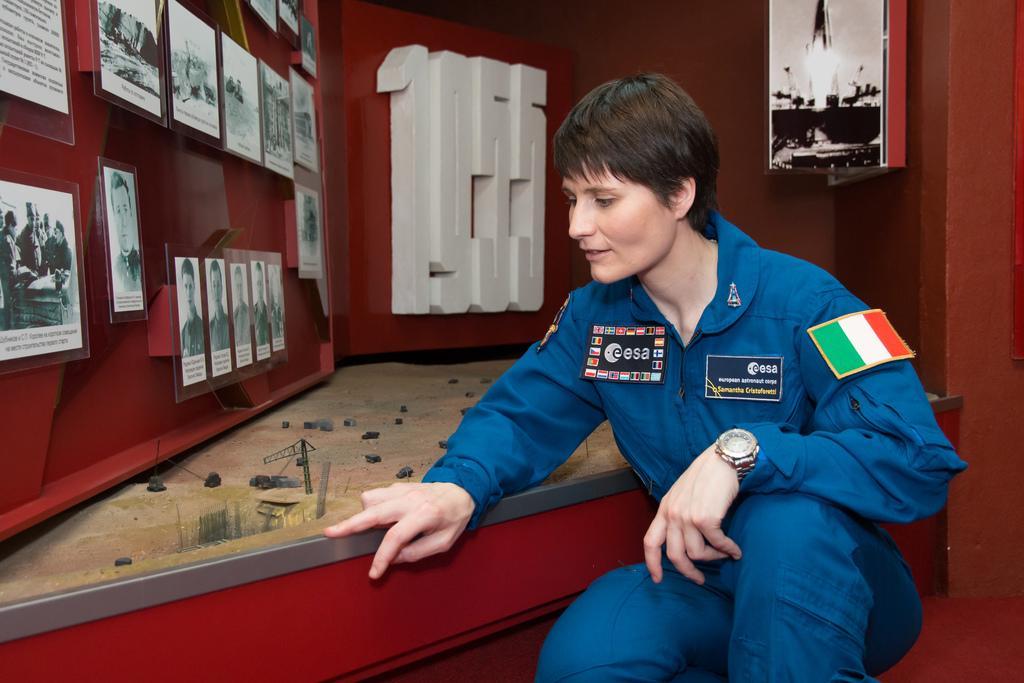Can you describe this image briefly? On the right side of this image there is a person wearing a uniform and sitting on the knees. Beside her there is an object which is looking like a table. On this there is a board on which few photo frames are attached. In the background there is a red color wall. At the top there is a board is attached to the wall. 